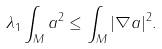<formula> <loc_0><loc_0><loc_500><loc_500>\lambda _ { 1 } \int _ { M } a ^ { 2 } \leq \int _ { M } | \nabla a | ^ { 2 } .</formula> 